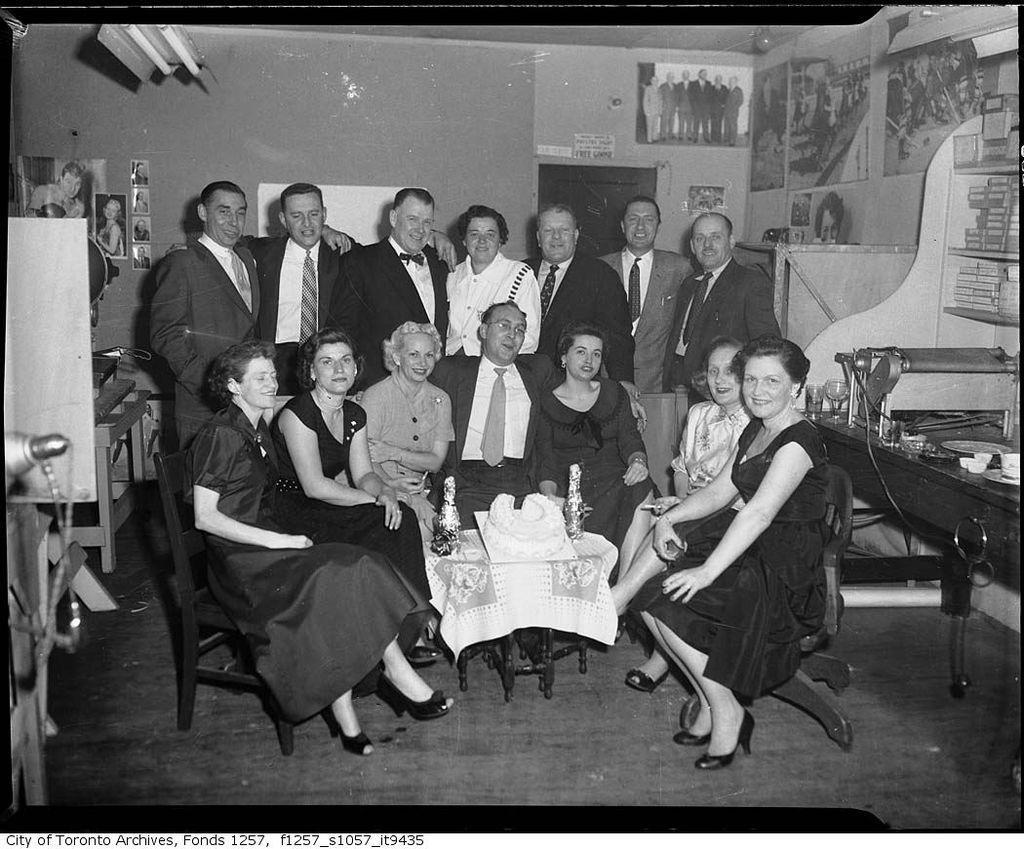Describe this image in one or two sentences. As we can see in the image there is a wall, few people standing and sitting over here and there is a table and on table there are bottles. 